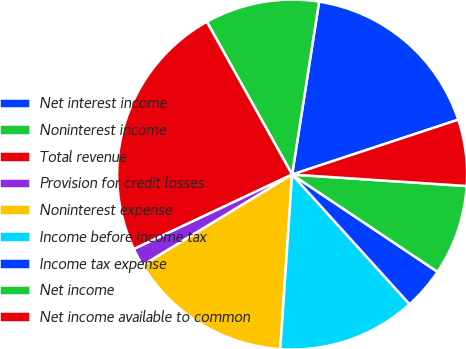Convert chart to OTSL. <chart><loc_0><loc_0><loc_500><loc_500><pie_chart><fcel>Net interest income<fcel>Noninterest income<fcel>Total revenue<fcel>Provision for credit losses<fcel>Noninterest expense<fcel>Income before income tax<fcel>Income tax expense<fcel>Net income<fcel>Net income available to common<nl><fcel>17.46%<fcel>10.57%<fcel>23.9%<fcel>1.68%<fcel>15.24%<fcel>12.79%<fcel>3.9%<fcel>8.34%<fcel>6.12%<nl></chart> 